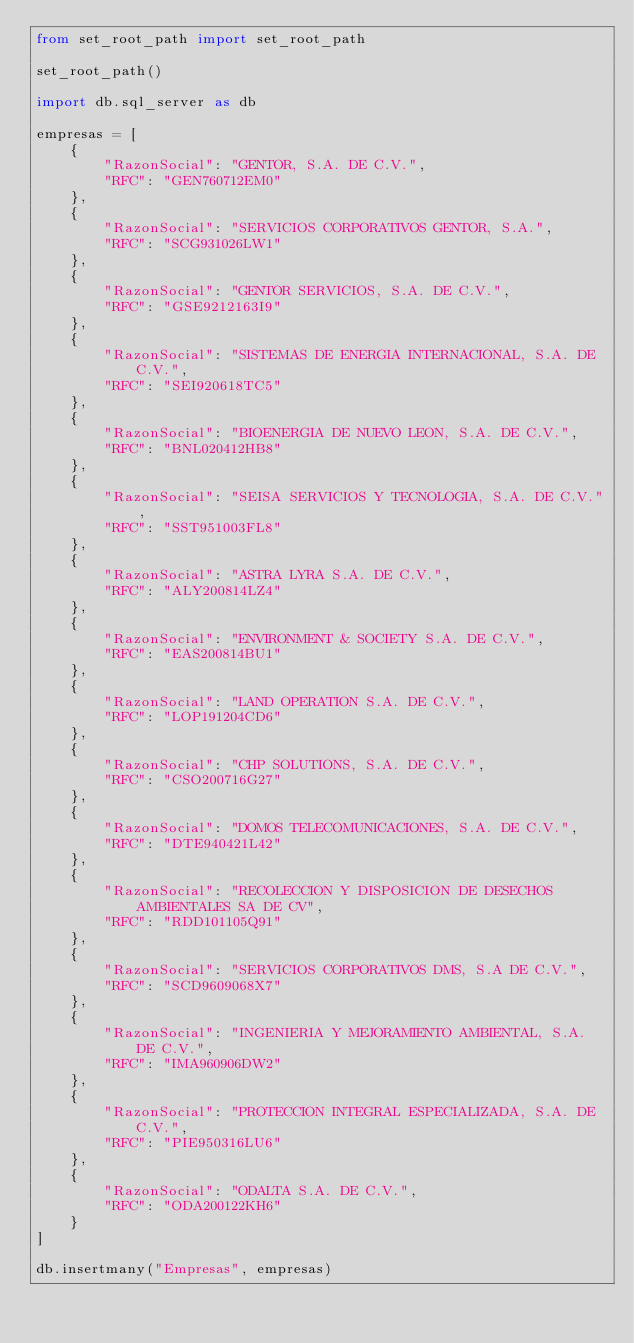<code> <loc_0><loc_0><loc_500><loc_500><_Python_>from set_root_path import set_root_path

set_root_path()

import db.sql_server as db

empresas = [
    {
        "RazonSocial": "GENTOR, S.A. DE C.V.",
        "RFC": "GEN760712EM0"
    },
    {
        "RazonSocial": "SERVICIOS CORPORATIVOS GENTOR, S.A.",
        "RFC": "SCG931026LW1"
    },
    {
        "RazonSocial": "GENTOR SERVICIOS, S.A. DE C.V.",
        "RFC": "GSE9212163I9"
    },
    {
        "RazonSocial": "SISTEMAS DE ENERGIA INTERNACIONAL, S.A. DE C.V.",
        "RFC": "SEI920618TC5"
    },
    {
        "RazonSocial": "BIOENERGIA DE NUEVO LEON, S.A. DE C.V.",
        "RFC": "BNL020412HB8"
    },
    {
        "RazonSocial": "SEISA SERVICIOS Y TECNOLOGIA, S.A. DE C.V.",
        "RFC": "SST951003FL8"
    },
    {
        "RazonSocial": "ASTRA LYRA S.A. DE C.V.",
        "RFC": "ALY200814LZ4"
    },
    {
        "RazonSocial": "ENVIRONMENT & SOCIETY S.A. DE C.V.",
        "RFC": "EAS200814BU1"
    },
    {
        "RazonSocial": "LAND OPERATION S.A. DE C.V.",
        "RFC": "LOP191204CD6"
    },
    {
        "RazonSocial": "CHP SOLUTIONS, S.A. DE C.V.",
        "RFC": "CSO200716G27"
    },
    {
        "RazonSocial": "DOMOS TELECOMUNICACIONES, S.A. DE C.V.",
        "RFC": "DTE940421L42"
    },
    {
        "RazonSocial": "RECOLECCION Y DISPOSICION DE DESECHOS AMBIENTALES SA DE CV",
        "RFC": "RDD101105Q91"
    },
    {
        "RazonSocial": "SERVICIOS CORPORATIVOS DMS, S.A DE C.V.",
        "RFC": "SCD9609068X7"
    },
    {
        "RazonSocial": "INGENIERIA Y MEJORAMIENTO AMBIENTAL, S.A. DE C.V.",
        "RFC": "IMA960906DW2"
    },
    {
        "RazonSocial": "PROTECCION INTEGRAL ESPECIALIZADA, S.A. DE C.V.",
        "RFC": "PIE950316LU6"
    },
    {
        "RazonSocial": "ODALTA S.A. DE C.V.",
        "RFC": "ODA200122KH6"
    }
]

db.insertmany("Empresas", empresas)
</code> 